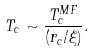<formula> <loc_0><loc_0><loc_500><loc_500>T _ { c } \sim \frac { T _ { c } ^ { M F } } { ( r _ { c } / \xi ) } .</formula> 